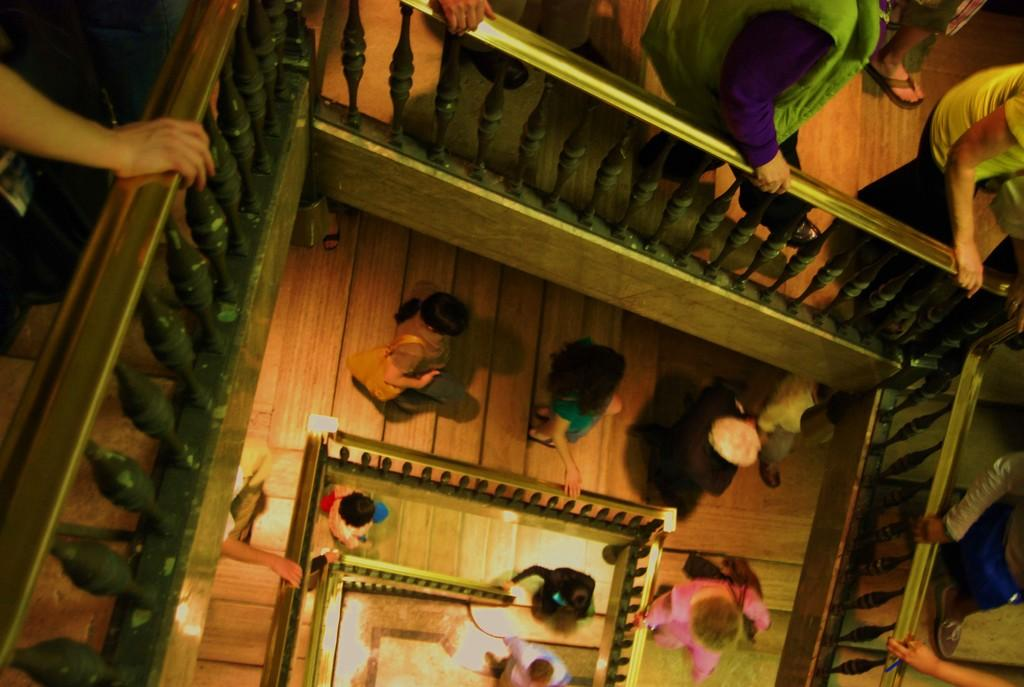What are the people in the image doing? The people in the image are walking down on the wooden stairs. What is the wooden railing used for? The wooden railing is likely used for support or safety while walking down the stairs. What can be seen in the image that provides illumination? There are lights visible in the image. Where is the mailbox located in the image? There is no mailbox present in the image. What type of donkey can be seen walking alongside the people in the image? There is no donkey present in the image; only people walking down the stairs are visible. 